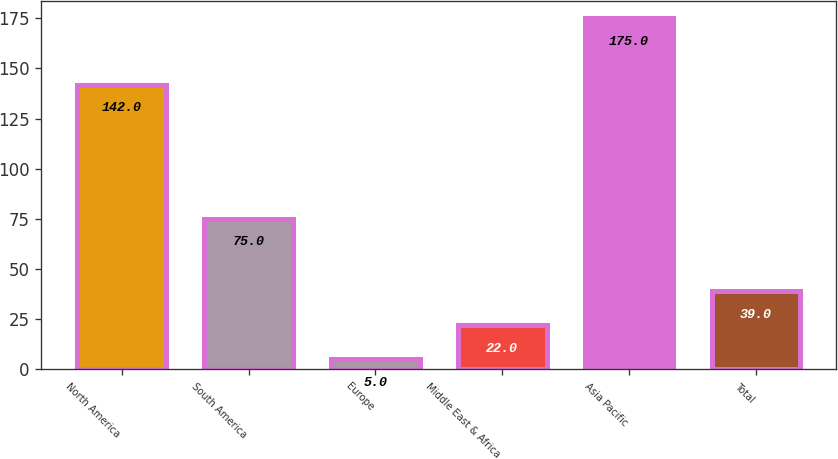<chart> <loc_0><loc_0><loc_500><loc_500><bar_chart><fcel>North America<fcel>South America<fcel>Europe<fcel>Middle East & Africa<fcel>Asia Pacific<fcel>Total<nl><fcel>142<fcel>75<fcel>5<fcel>22<fcel>175<fcel>39<nl></chart> 